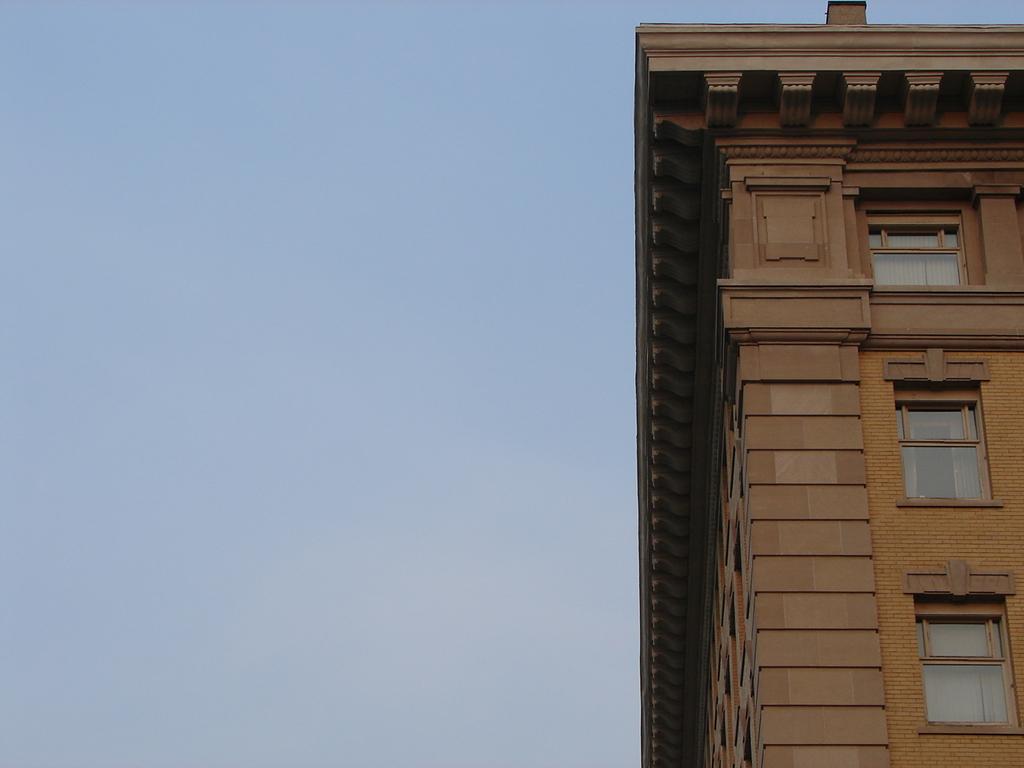Could you give a brief overview of what you see in this image? In this picture we can see a building with windows. Behind the building there is the sky. 